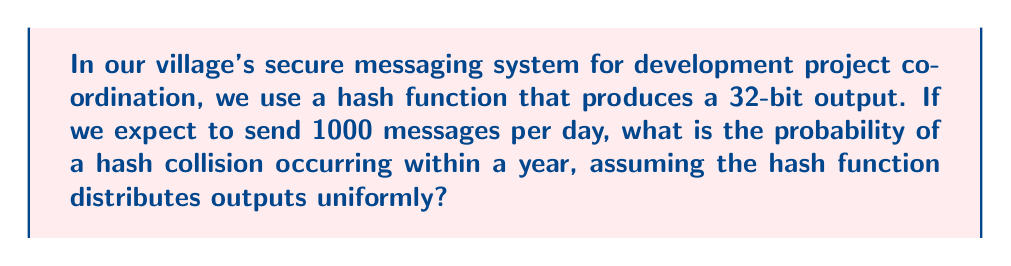Help me with this question. Let's approach this step-by-step using the birthday problem and its application to hash collisions:

1) First, we need to calculate the number of messages sent in a year:
   $$ 1000 \text{ messages/day} \times 365 \text{ days} = 365,000 \text{ messages/year} $$

2) The hash function produces a 32-bit output, so the total number of possible hash values is:
   $$ 2^{32} = 4,294,967,296 $$

3) We can use the birthday problem formula to calculate the probability of at least one collision:
   $$ P(\text{at least one collision}) = 1 - P(\text{no collisions}) $$
   $$ = 1 - \frac{n!}{n^m(n-m)!} $$
   
   Where $n$ is the number of possible hash values and $m$ is the number of messages.

4) However, for large $n$ and $m$, we can use the approximation:
   $$ P(\text{at least one collision}) \approx 1 - e^{-\frac{m^2}{2n}} $$

5) Plugging in our values:
   $$ P(\text{collision}) \approx 1 - e^{-\frac{365,000^2}{2 \times 4,294,967,296}} $$

6) Calculating:
   $$ \approx 1 - e^{-15.51} $$
   $$ \approx 1 - 1.83 \times 10^{-7} $$
   $$ \approx 0.99999982 $$

7) Converting to a percentage:
   $$ 0.99999982 \times 100\% \approx 99.999982\% $$
Answer: 99.999982% 